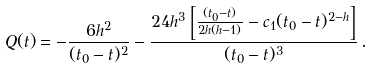Convert formula to latex. <formula><loc_0><loc_0><loc_500><loc_500>Q ( t ) = - \frac { 6 h ^ { 2 } } { ( t _ { 0 } - t ) ^ { 2 } } - \frac { 2 4 h ^ { 3 } \left [ \frac { ( t _ { 0 } - t ) } { 2 h ( h - 1 ) } - c _ { 1 } ( t _ { 0 } - t ) ^ { 2 - h } \right ] } { ( t _ { 0 } - t ) ^ { 3 } } \, .</formula> 